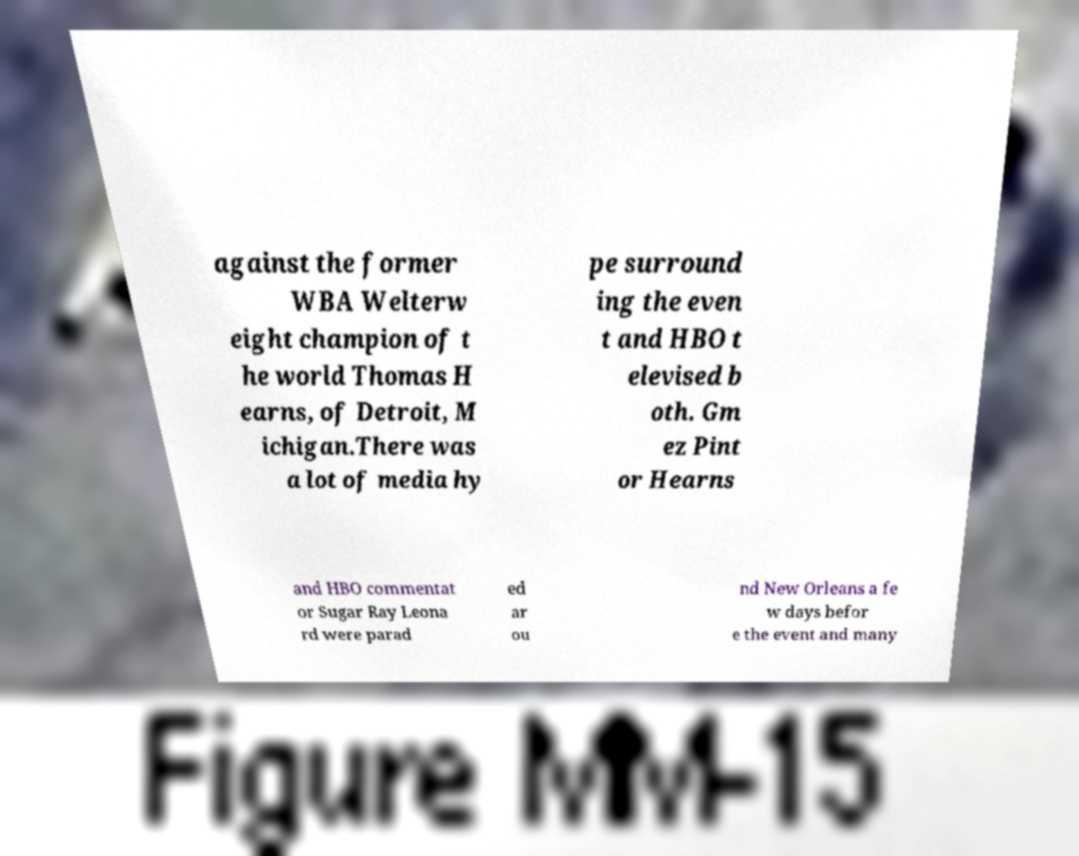Can you accurately transcribe the text from the provided image for me? against the former WBA Welterw eight champion of t he world Thomas H earns, of Detroit, M ichigan.There was a lot of media hy pe surround ing the even t and HBO t elevised b oth. Gm ez Pint or Hearns and HBO commentat or Sugar Ray Leona rd were parad ed ar ou nd New Orleans a fe w days befor e the event and many 